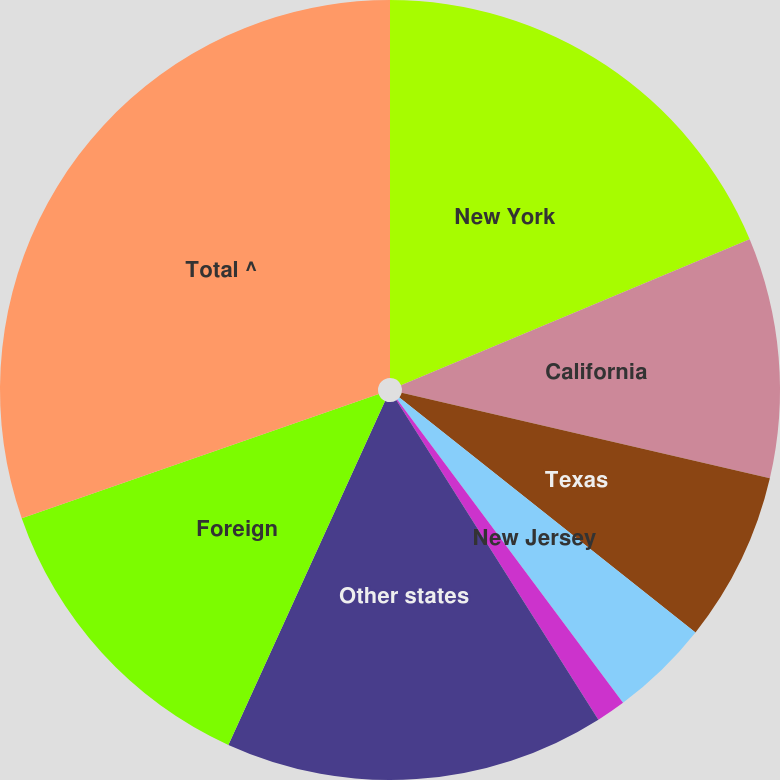Convert chart. <chart><loc_0><loc_0><loc_500><loc_500><pie_chart><fcel>New York<fcel>California<fcel>Texas<fcel>New Jersey<fcel>Florida<fcel>Other states<fcel>Foreign<fcel>Total ^<nl><fcel>18.68%<fcel>9.95%<fcel>7.04%<fcel>4.13%<fcel>1.22%<fcel>15.77%<fcel>12.86%<fcel>30.33%<nl></chart> 